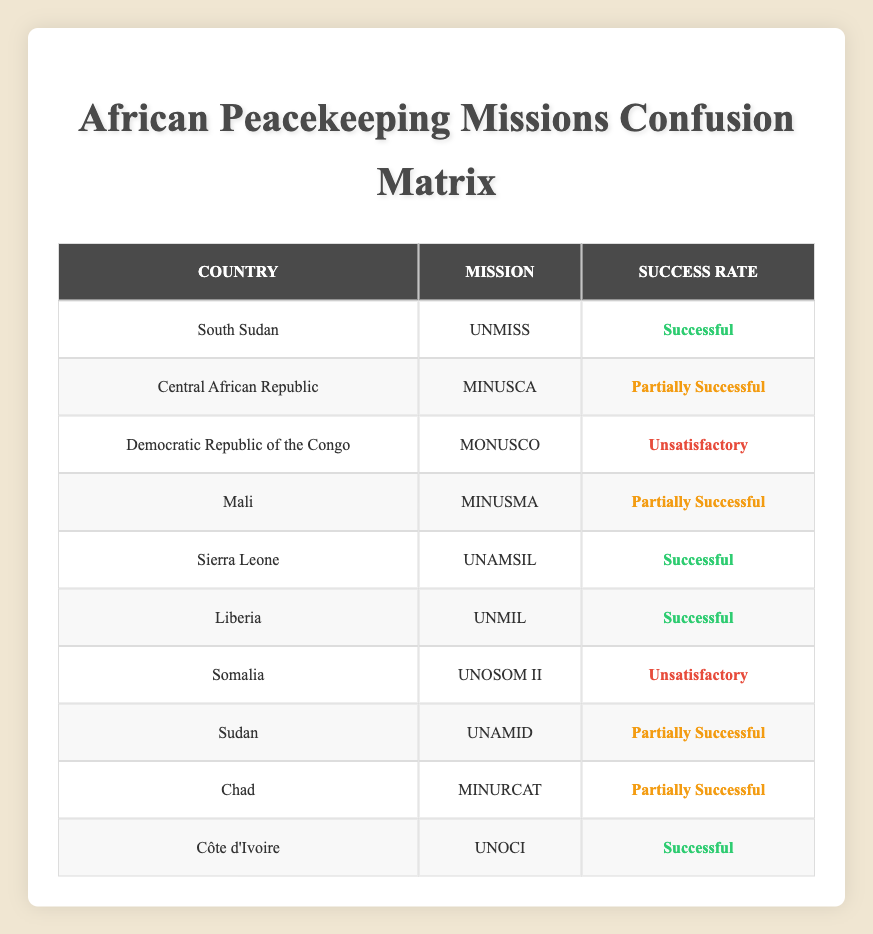What is the total number of peacekeeping missions listed in the table? The table contains 10 rows, each representing a peacekeeping mission in a different country. Therefore, the total number of peacekeeping missions is 10.
Answer: 10 Which country had the mission UNMIL? According to the table, the UNMIL mission was in Liberia. The relevant row indicates that Liberia is associated with the UNMIL mission.
Answer: Liberia How many missions are classified as "Successful"? In the table, three missions are marked as "Successful" - UNMISS (South Sudan), UNAMSIL (Sierra Leone), and UNOCI (Côte d'Ivoire). By counting these three rows, we find the answer.
Answer: 3 Is the success rate of the mission in Somalia satisfactory? The table shows that the mission in Somalia (UNOSOM II) is classified as "Unsatisfactory." Therefore, the success rate is not satisfactory.
Answer: No What percentage of the missions are classified as "Partially Successful"? There are four missions listed as "Partially Successful" (MINUSCA, MINUSMA, UNAMID, MINURCAT) out of a total of ten missions. To find the percentage, we calculate (4/10) * 100 = 40%.
Answer: 40% Which mission had the lowest success classification? The mission with the lowest success classification in the table is UNOSOM II, which is categorized as "Unsatisfactory." This can be determined by comparing the success rates in the corresponding rows.
Answer: UNOSOM II How many missions were deemed unsatisfactory compared to successful ones? There are three missions marked as unsatisfactory (MONUSCO and UNOSOM II) and three missions marked as successful (UNMISS, UNAMSIL, UNOCI). Therefore, the count of unsatisfactory missions equals the count of successful missions, which makes it an even comparison.
Answer: Equal (3 each) What is the ratio of successful missions to total missions? There are 3 successful missions out of a total of 10 missions. Therefore, the ratio can be calculated as 3 successful missions to 10 total missions, which simplifies to 3:10.
Answer: 3:10 